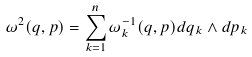Convert formula to latex. <formula><loc_0><loc_0><loc_500><loc_500>\omega ^ { 2 } ( q , p ) = \sum _ { k = 1 } ^ { n } \omega ^ { - 1 } _ { k } ( q , p ) d q _ { k } \wedge d p _ { k }</formula> 